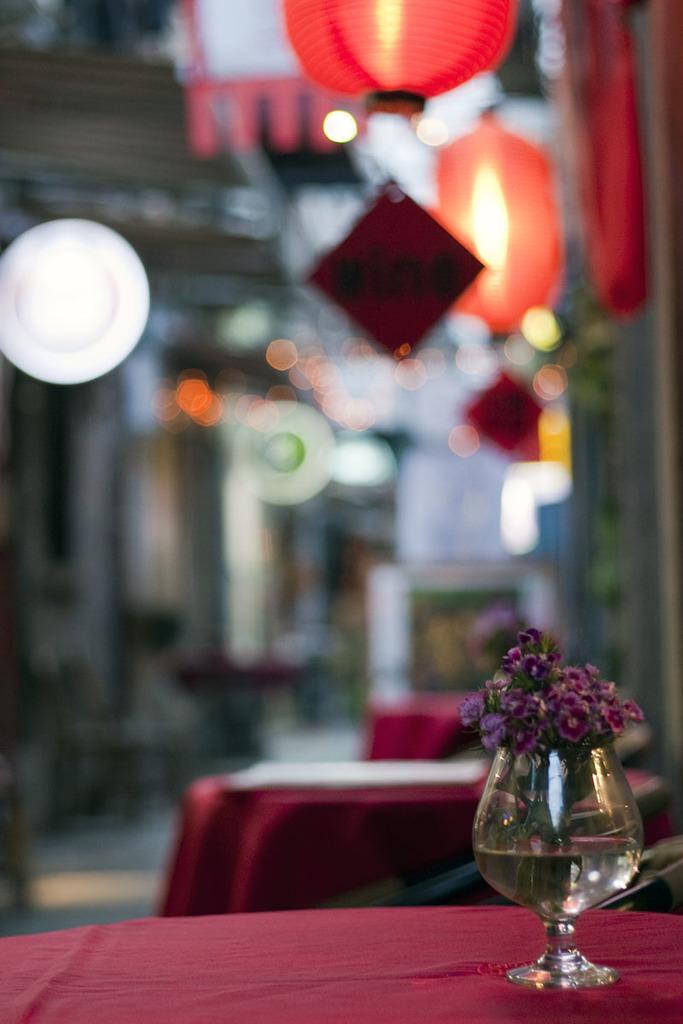Please provide a concise description of this image. In this image I see a glass in which there are flowers and the glass is on a table. 